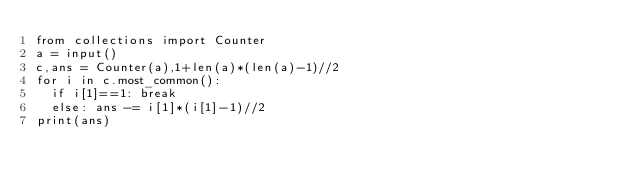Convert code to text. <code><loc_0><loc_0><loc_500><loc_500><_Python_>from collections import Counter
a = input()
c,ans = Counter(a),1+len(a)*(len(a)-1)//2
for i in c.most_common():
	if i[1]==1: break
	else: ans -= i[1]*(i[1]-1)//2
print(ans)</code> 